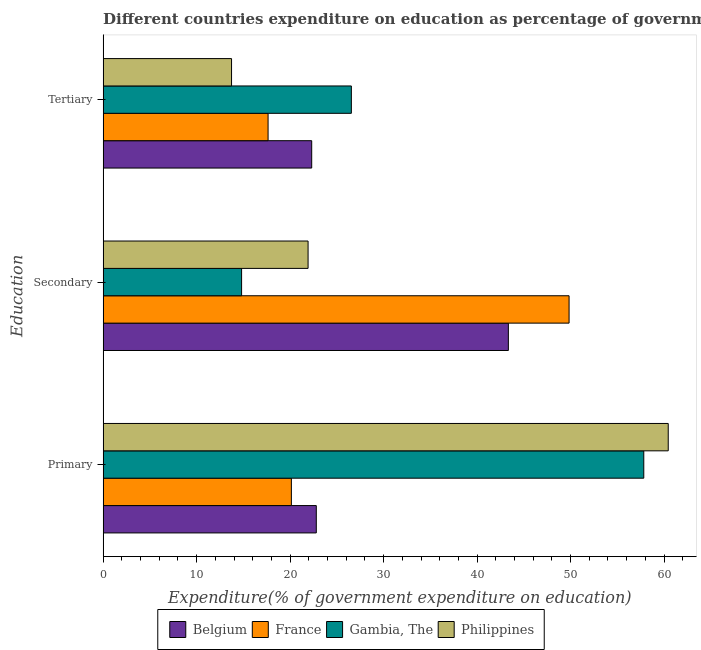How many different coloured bars are there?
Provide a succinct answer. 4. How many groups of bars are there?
Ensure brevity in your answer.  3. Are the number of bars on each tick of the Y-axis equal?
Give a very brief answer. Yes. How many bars are there on the 1st tick from the bottom?
Offer a very short reply. 4. What is the label of the 3rd group of bars from the top?
Ensure brevity in your answer.  Primary. What is the expenditure on primary education in Philippines?
Keep it short and to the point. 60.45. Across all countries, what is the maximum expenditure on secondary education?
Make the answer very short. 49.84. Across all countries, what is the minimum expenditure on secondary education?
Make the answer very short. 14.81. In which country was the expenditure on secondary education maximum?
Keep it short and to the point. France. In which country was the expenditure on secondary education minimum?
Provide a succinct answer. Gambia, The. What is the total expenditure on tertiary education in the graph?
Your response must be concise. 80.24. What is the difference between the expenditure on secondary education in Philippines and that in France?
Your answer should be very brief. -27.92. What is the difference between the expenditure on secondary education in Belgium and the expenditure on tertiary education in Philippines?
Give a very brief answer. 29.61. What is the average expenditure on tertiary education per country?
Give a very brief answer. 20.06. What is the difference between the expenditure on secondary education and expenditure on primary education in Belgium?
Your response must be concise. 20.55. What is the ratio of the expenditure on tertiary education in Belgium to that in Gambia, The?
Keep it short and to the point. 0.84. Is the expenditure on tertiary education in Belgium less than that in Philippines?
Give a very brief answer. No. Is the difference between the expenditure on primary education in Belgium and Gambia, The greater than the difference between the expenditure on tertiary education in Belgium and Gambia, The?
Provide a short and direct response. No. What is the difference between the highest and the second highest expenditure on secondary education?
Keep it short and to the point. 6.49. What is the difference between the highest and the lowest expenditure on tertiary education?
Your response must be concise. 12.82. What does the 4th bar from the top in Primary represents?
Your answer should be compact. Belgium. How many countries are there in the graph?
Provide a short and direct response. 4. What is the difference between two consecutive major ticks on the X-axis?
Your answer should be very brief. 10. Are the values on the major ticks of X-axis written in scientific E-notation?
Offer a terse response. No. Does the graph contain any zero values?
Provide a short and direct response. No. Where does the legend appear in the graph?
Provide a short and direct response. Bottom center. How many legend labels are there?
Your response must be concise. 4. What is the title of the graph?
Give a very brief answer. Different countries expenditure on education as percentage of government expenditure. Does "Angola" appear as one of the legend labels in the graph?
Your answer should be compact. No. What is the label or title of the X-axis?
Your answer should be compact. Expenditure(% of government expenditure on education). What is the label or title of the Y-axis?
Give a very brief answer. Education. What is the Expenditure(% of government expenditure on education) in Belgium in Primary?
Offer a very short reply. 22.8. What is the Expenditure(% of government expenditure on education) of France in Primary?
Offer a terse response. 20.13. What is the Expenditure(% of government expenditure on education) in Gambia, The in Primary?
Make the answer very short. 57.83. What is the Expenditure(% of government expenditure on education) in Philippines in Primary?
Provide a succinct answer. 60.45. What is the Expenditure(% of government expenditure on education) of Belgium in Secondary?
Your answer should be very brief. 43.35. What is the Expenditure(% of government expenditure on education) of France in Secondary?
Your answer should be compact. 49.84. What is the Expenditure(% of government expenditure on education) in Gambia, The in Secondary?
Your answer should be very brief. 14.81. What is the Expenditure(% of government expenditure on education) of Philippines in Secondary?
Provide a short and direct response. 21.92. What is the Expenditure(% of government expenditure on education) in Belgium in Tertiary?
Provide a succinct answer. 22.31. What is the Expenditure(% of government expenditure on education) in France in Tertiary?
Offer a very short reply. 17.64. What is the Expenditure(% of government expenditure on education) of Gambia, The in Tertiary?
Provide a short and direct response. 26.55. What is the Expenditure(% of government expenditure on education) of Philippines in Tertiary?
Offer a terse response. 13.73. Across all Education, what is the maximum Expenditure(% of government expenditure on education) of Belgium?
Ensure brevity in your answer.  43.35. Across all Education, what is the maximum Expenditure(% of government expenditure on education) in France?
Provide a short and direct response. 49.84. Across all Education, what is the maximum Expenditure(% of government expenditure on education) of Gambia, The?
Your response must be concise. 57.83. Across all Education, what is the maximum Expenditure(% of government expenditure on education) of Philippines?
Ensure brevity in your answer.  60.45. Across all Education, what is the minimum Expenditure(% of government expenditure on education) of Belgium?
Offer a very short reply. 22.31. Across all Education, what is the minimum Expenditure(% of government expenditure on education) of France?
Provide a succinct answer. 17.64. Across all Education, what is the minimum Expenditure(% of government expenditure on education) in Gambia, The?
Offer a very short reply. 14.81. Across all Education, what is the minimum Expenditure(% of government expenditure on education) of Philippines?
Ensure brevity in your answer.  13.73. What is the total Expenditure(% of government expenditure on education) of Belgium in the graph?
Give a very brief answer. 88.46. What is the total Expenditure(% of government expenditure on education) in France in the graph?
Ensure brevity in your answer.  87.62. What is the total Expenditure(% of government expenditure on education) of Gambia, The in the graph?
Provide a short and direct response. 99.19. What is the total Expenditure(% of government expenditure on education) in Philippines in the graph?
Offer a very short reply. 96.1. What is the difference between the Expenditure(% of government expenditure on education) of Belgium in Primary and that in Secondary?
Your response must be concise. -20.55. What is the difference between the Expenditure(% of government expenditure on education) of France in Primary and that in Secondary?
Your answer should be very brief. -29.71. What is the difference between the Expenditure(% of government expenditure on education) in Gambia, The in Primary and that in Secondary?
Offer a terse response. 43.02. What is the difference between the Expenditure(% of government expenditure on education) in Philippines in Primary and that in Secondary?
Make the answer very short. 38.52. What is the difference between the Expenditure(% of government expenditure on education) of Belgium in Primary and that in Tertiary?
Offer a very short reply. 0.49. What is the difference between the Expenditure(% of government expenditure on education) in France in Primary and that in Tertiary?
Keep it short and to the point. 2.49. What is the difference between the Expenditure(% of government expenditure on education) of Gambia, The in Primary and that in Tertiary?
Ensure brevity in your answer.  31.28. What is the difference between the Expenditure(% of government expenditure on education) of Philippines in Primary and that in Tertiary?
Provide a succinct answer. 46.71. What is the difference between the Expenditure(% of government expenditure on education) of Belgium in Secondary and that in Tertiary?
Your response must be concise. 21.04. What is the difference between the Expenditure(% of government expenditure on education) in France in Secondary and that in Tertiary?
Your answer should be compact. 32.2. What is the difference between the Expenditure(% of government expenditure on education) in Gambia, The in Secondary and that in Tertiary?
Offer a terse response. -11.74. What is the difference between the Expenditure(% of government expenditure on education) of Philippines in Secondary and that in Tertiary?
Your answer should be very brief. 8.19. What is the difference between the Expenditure(% of government expenditure on education) in Belgium in Primary and the Expenditure(% of government expenditure on education) in France in Secondary?
Your answer should be compact. -27.04. What is the difference between the Expenditure(% of government expenditure on education) of Belgium in Primary and the Expenditure(% of government expenditure on education) of Gambia, The in Secondary?
Ensure brevity in your answer.  7.99. What is the difference between the Expenditure(% of government expenditure on education) in Belgium in Primary and the Expenditure(% of government expenditure on education) in Philippines in Secondary?
Your answer should be very brief. 0.88. What is the difference between the Expenditure(% of government expenditure on education) in France in Primary and the Expenditure(% of government expenditure on education) in Gambia, The in Secondary?
Your answer should be very brief. 5.32. What is the difference between the Expenditure(% of government expenditure on education) in France in Primary and the Expenditure(% of government expenditure on education) in Philippines in Secondary?
Make the answer very short. -1.79. What is the difference between the Expenditure(% of government expenditure on education) of Gambia, The in Primary and the Expenditure(% of government expenditure on education) of Philippines in Secondary?
Provide a succinct answer. 35.91. What is the difference between the Expenditure(% of government expenditure on education) of Belgium in Primary and the Expenditure(% of government expenditure on education) of France in Tertiary?
Provide a succinct answer. 5.16. What is the difference between the Expenditure(% of government expenditure on education) in Belgium in Primary and the Expenditure(% of government expenditure on education) in Gambia, The in Tertiary?
Keep it short and to the point. -3.75. What is the difference between the Expenditure(% of government expenditure on education) of Belgium in Primary and the Expenditure(% of government expenditure on education) of Philippines in Tertiary?
Your answer should be compact. 9.07. What is the difference between the Expenditure(% of government expenditure on education) in France in Primary and the Expenditure(% of government expenditure on education) in Gambia, The in Tertiary?
Your answer should be compact. -6.42. What is the difference between the Expenditure(% of government expenditure on education) in France in Primary and the Expenditure(% of government expenditure on education) in Philippines in Tertiary?
Your answer should be compact. 6.4. What is the difference between the Expenditure(% of government expenditure on education) in Gambia, The in Primary and the Expenditure(% of government expenditure on education) in Philippines in Tertiary?
Ensure brevity in your answer.  44.1. What is the difference between the Expenditure(% of government expenditure on education) in Belgium in Secondary and the Expenditure(% of government expenditure on education) in France in Tertiary?
Your response must be concise. 25.7. What is the difference between the Expenditure(% of government expenditure on education) in Belgium in Secondary and the Expenditure(% of government expenditure on education) in Gambia, The in Tertiary?
Provide a succinct answer. 16.79. What is the difference between the Expenditure(% of government expenditure on education) of Belgium in Secondary and the Expenditure(% of government expenditure on education) of Philippines in Tertiary?
Offer a very short reply. 29.61. What is the difference between the Expenditure(% of government expenditure on education) of France in Secondary and the Expenditure(% of government expenditure on education) of Gambia, The in Tertiary?
Offer a very short reply. 23.29. What is the difference between the Expenditure(% of government expenditure on education) of France in Secondary and the Expenditure(% of government expenditure on education) of Philippines in Tertiary?
Provide a succinct answer. 36.11. What is the difference between the Expenditure(% of government expenditure on education) of Gambia, The in Secondary and the Expenditure(% of government expenditure on education) of Philippines in Tertiary?
Your answer should be very brief. 1.08. What is the average Expenditure(% of government expenditure on education) of Belgium per Education?
Provide a succinct answer. 29.49. What is the average Expenditure(% of government expenditure on education) in France per Education?
Give a very brief answer. 29.21. What is the average Expenditure(% of government expenditure on education) of Gambia, The per Education?
Your response must be concise. 33.06. What is the average Expenditure(% of government expenditure on education) in Philippines per Education?
Keep it short and to the point. 32.03. What is the difference between the Expenditure(% of government expenditure on education) in Belgium and Expenditure(% of government expenditure on education) in France in Primary?
Make the answer very short. 2.67. What is the difference between the Expenditure(% of government expenditure on education) of Belgium and Expenditure(% of government expenditure on education) of Gambia, The in Primary?
Provide a succinct answer. -35.03. What is the difference between the Expenditure(% of government expenditure on education) of Belgium and Expenditure(% of government expenditure on education) of Philippines in Primary?
Your answer should be very brief. -37.65. What is the difference between the Expenditure(% of government expenditure on education) of France and Expenditure(% of government expenditure on education) of Gambia, The in Primary?
Offer a terse response. -37.7. What is the difference between the Expenditure(% of government expenditure on education) of France and Expenditure(% of government expenditure on education) of Philippines in Primary?
Your answer should be very brief. -40.31. What is the difference between the Expenditure(% of government expenditure on education) in Gambia, The and Expenditure(% of government expenditure on education) in Philippines in Primary?
Ensure brevity in your answer.  -2.62. What is the difference between the Expenditure(% of government expenditure on education) in Belgium and Expenditure(% of government expenditure on education) in France in Secondary?
Keep it short and to the point. -6.49. What is the difference between the Expenditure(% of government expenditure on education) of Belgium and Expenditure(% of government expenditure on education) of Gambia, The in Secondary?
Keep it short and to the point. 28.53. What is the difference between the Expenditure(% of government expenditure on education) of Belgium and Expenditure(% of government expenditure on education) of Philippines in Secondary?
Your response must be concise. 21.42. What is the difference between the Expenditure(% of government expenditure on education) of France and Expenditure(% of government expenditure on education) of Gambia, The in Secondary?
Ensure brevity in your answer.  35.03. What is the difference between the Expenditure(% of government expenditure on education) in France and Expenditure(% of government expenditure on education) in Philippines in Secondary?
Keep it short and to the point. 27.92. What is the difference between the Expenditure(% of government expenditure on education) in Gambia, The and Expenditure(% of government expenditure on education) in Philippines in Secondary?
Ensure brevity in your answer.  -7.11. What is the difference between the Expenditure(% of government expenditure on education) of Belgium and Expenditure(% of government expenditure on education) of France in Tertiary?
Make the answer very short. 4.67. What is the difference between the Expenditure(% of government expenditure on education) of Belgium and Expenditure(% of government expenditure on education) of Gambia, The in Tertiary?
Give a very brief answer. -4.24. What is the difference between the Expenditure(% of government expenditure on education) in Belgium and Expenditure(% of government expenditure on education) in Philippines in Tertiary?
Offer a very short reply. 8.57. What is the difference between the Expenditure(% of government expenditure on education) of France and Expenditure(% of government expenditure on education) of Gambia, The in Tertiary?
Offer a terse response. -8.91. What is the difference between the Expenditure(% of government expenditure on education) in France and Expenditure(% of government expenditure on education) in Philippines in Tertiary?
Provide a succinct answer. 3.91. What is the difference between the Expenditure(% of government expenditure on education) in Gambia, The and Expenditure(% of government expenditure on education) in Philippines in Tertiary?
Provide a succinct answer. 12.82. What is the ratio of the Expenditure(% of government expenditure on education) of Belgium in Primary to that in Secondary?
Ensure brevity in your answer.  0.53. What is the ratio of the Expenditure(% of government expenditure on education) in France in Primary to that in Secondary?
Keep it short and to the point. 0.4. What is the ratio of the Expenditure(% of government expenditure on education) of Gambia, The in Primary to that in Secondary?
Provide a succinct answer. 3.9. What is the ratio of the Expenditure(% of government expenditure on education) in Philippines in Primary to that in Secondary?
Your response must be concise. 2.76. What is the ratio of the Expenditure(% of government expenditure on education) in Belgium in Primary to that in Tertiary?
Provide a succinct answer. 1.02. What is the ratio of the Expenditure(% of government expenditure on education) of France in Primary to that in Tertiary?
Make the answer very short. 1.14. What is the ratio of the Expenditure(% of government expenditure on education) of Gambia, The in Primary to that in Tertiary?
Ensure brevity in your answer.  2.18. What is the ratio of the Expenditure(% of government expenditure on education) of Philippines in Primary to that in Tertiary?
Give a very brief answer. 4.4. What is the ratio of the Expenditure(% of government expenditure on education) of Belgium in Secondary to that in Tertiary?
Your response must be concise. 1.94. What is the ratio of the Expenditure(% of government expenditure on education) of France in Secondary to that in Tertiary?
Offer a terse response. 2.82. What is the ratio of the Expenditure(% of government expenditure on education) of Gambia, The in Secondary to that in Tertiary?
Keep it short and to the point. 0.56. What is the ratio of the Expenditure(% of government expenditure on education) in Philippines in Secondary to that in Tertiary?
Offer a terse response. 1.6. What is the difference between the highest and the second highest Expenditure(% of government expenditure on education) in Belgium?
Keep it short and to the point. 20.55. What is the difference between the highest and the second highest Expenditure(% of government expenditure on education) of France?
Ensure brevity in your answer.  29.71. What is the difference between the highest and the second highest Expenditure(% of government expenditure on education) of Gambia, The?
Give a very brief answer. 31.28. What is the difference between the highest and the second highest Expenditure(% of government expenditure on education) of Philippines?
Give a very brief answer. 38.52. What is the difference between the highest and the lowest Expenditure(% of government expenditure on education) in Belgium?
Ensure brevity in your answer.  21.04. What is the difference between the highest and the lowest Expenditure(% of government expenditure on education) in France?
Give a very brief answer. 32.2. What is the difference between the highest and the lowest Expenditure(% of government expenditure on education) of Gambia, The?
Provide a short and direct response. 43.02. What is the difference between the highest and the lowest Expenditure(% of government expenditure on education) of Philippines?
Offer a very short reply. 46.71. 